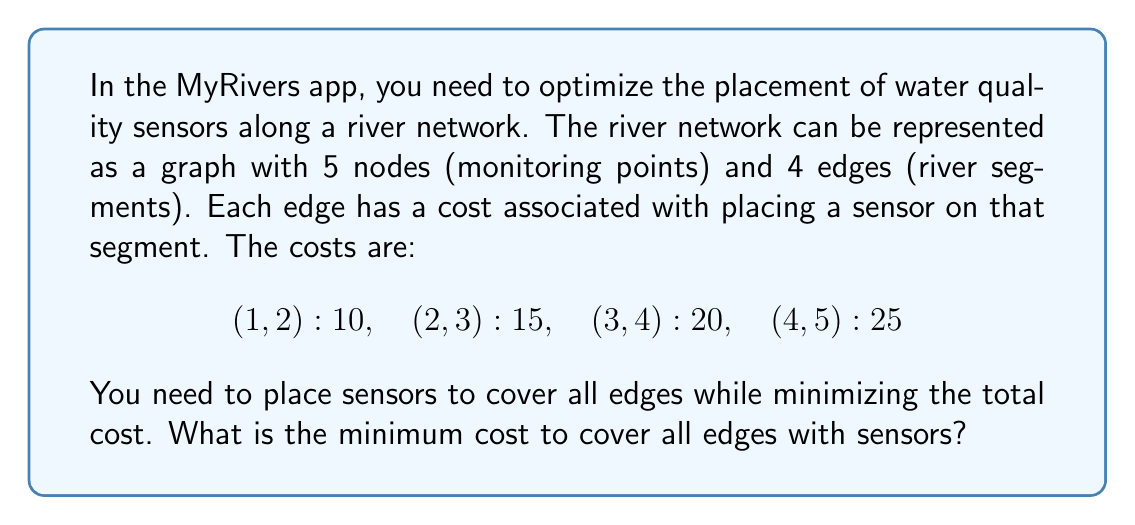Show me your answer to this math problem. To solve this problem, we can use a combination of graph theory and linear programming. Let's approach this step-by-step:

1) First, we need to understand that placing a sensor on a node covers all edges connected to that node.

2) We can formulate this as a Minimum Vertex Cover problem, which is equivalent to finding the minimum set of nodes that cover all edges.

3) Let's define binary variables for each node:
   $x_1, x_2, x_3, x_4, x_5$ where $x_i = 1$ if we place a sensor at node $i$, and 0 otherwise.

4) Our objective function to minimize is:
   $$\text{Minimize } 10x_1 + 25x_2 + 35x_3 + 45x_4 + 25x_5$$
   Where each coefficient is the sum of costs of edges connected to that node.

5) Our constraints ensure that each edge is covered:
   $$x_1 + x_2 \geq 1$$
   $$x_2 + x_3 \geq 1$$
   $$x_3 + x_4 \geq 1$$
   $$x_4 + x_5 \geq 1$$

6) Solving this linear program (which can be done using various algorithms like the Simplex method), we get the optimal solution:
   $x_1 = 1, x_3 = 1, x_5 = 1$, and $x_2 = x_4 = 0$

7) This means we should place sensors at nodes 1, 3, and 5.

8) The total cost is therefore:
   $$10 + 35 + 25 = 70$$
Answer: 70 